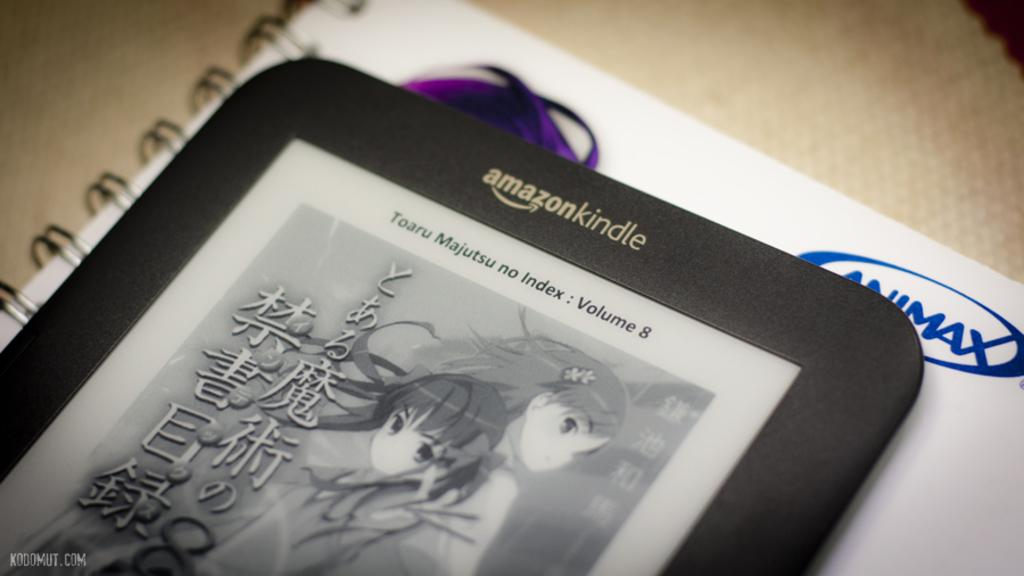<image>
Render a clear and concise summary of the photo. a amazonkindle turned on with a book on the screen 